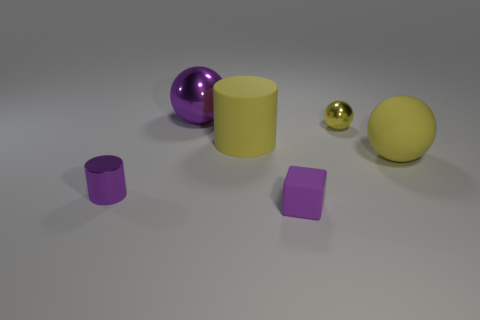Add 1 small blue spheres. How many objects exist? 7 Subtract all cylinders. How many objects are left? 4 Subtract all large purple spheres. Subtract all yellow matte cylinders. How many objects are left? 4 Add 4 small balls. How many small balls are left? 5 Add 5 purple metal spheres. How many purple metal spheres exist? 6 Subtract 0 blue balls. How many objects are left? 6 